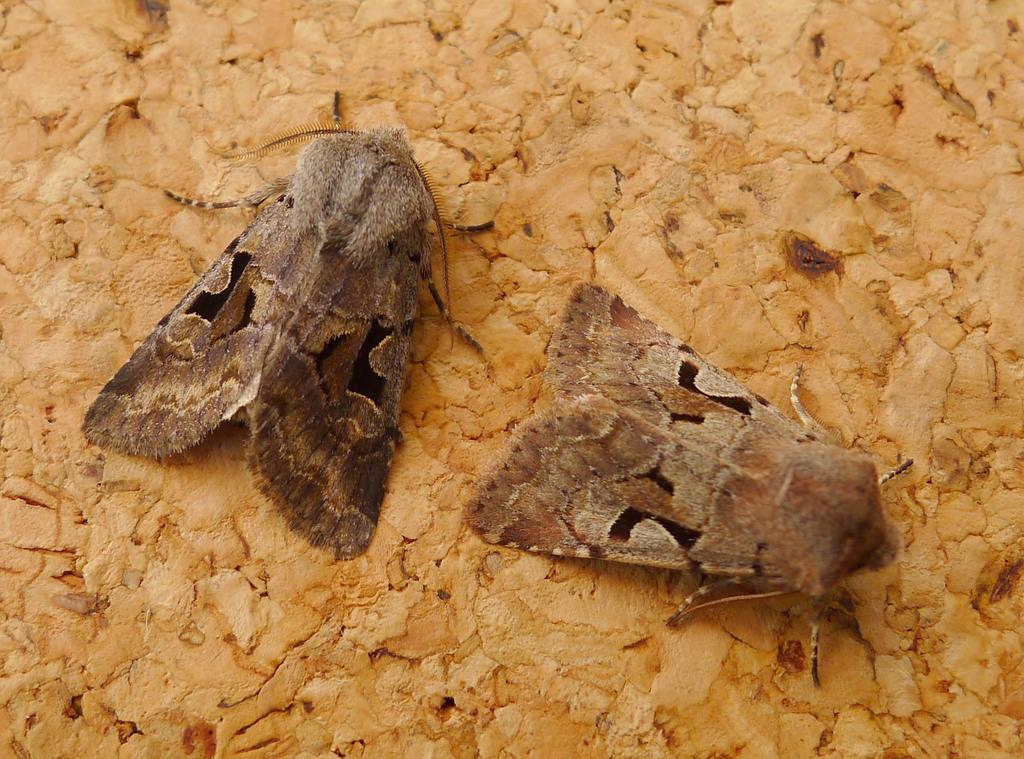What type of creatures can be seen in the image? There are insects in the image. What material is the background of the image made of? The background of the image appears to be made of wood. What type of milk is being served at the party in the image? There is no party or milk present in the image; it features insects and a wooden background. 